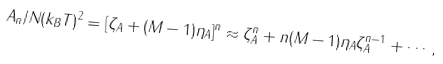Convert formula to latex. <formula><loc_0><loc_0><loc_500><loc_500>A _ { n } / N ( k _ { B } T ) ^ { 2 } = [ \zeta _ { A } + ( M - 1 ) \eta _ { A } ] ^ { n } \approx \zeta _ { A } ^ { n } + n ( M - 1 ) \eta _ { A } \zeta _ { A } ^ { n - 1 } + \cdots ,</formula> 